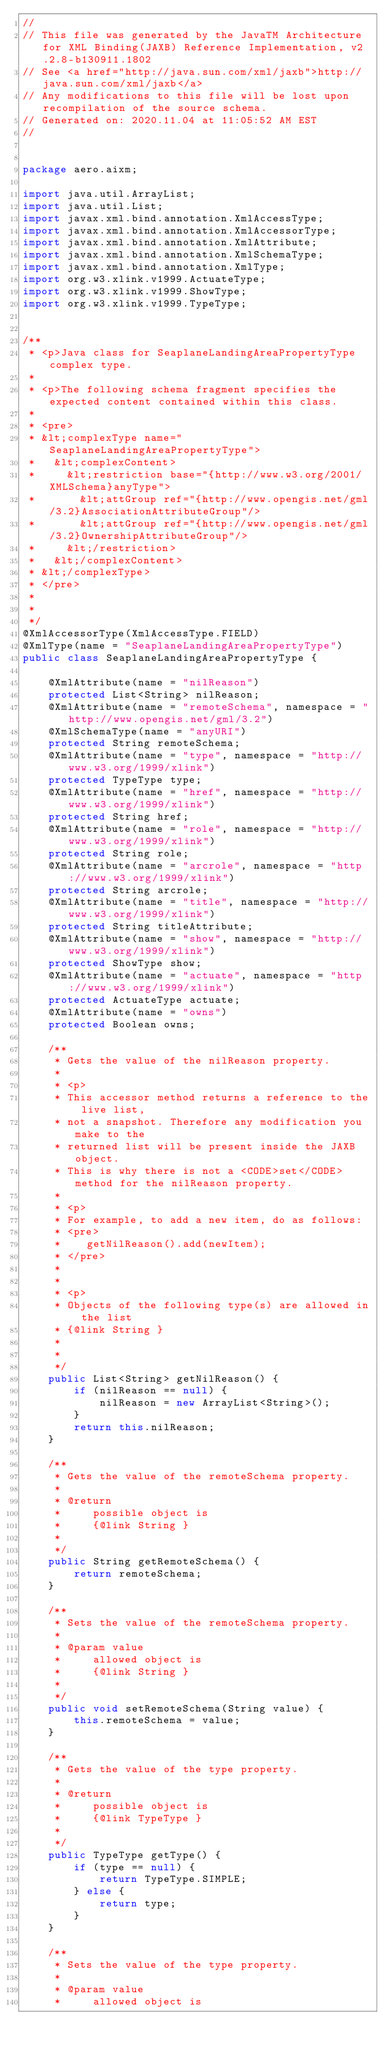<code> <loc_0><loc_0><loc_500><loc_500><_Java_>//
// This file was generated by the JavaTM Architecture for XML Binding(JAXB) Reference Implementation, v2.2.8-b130911.1802 
// See <a href="http://java.sun.com/xml/jaxb">http://java.sun.com/xml/jaxb</a> 
// Any modifications to this file will be lost upon recompilation of the source schema. 
// Generated on: 2020.11.04 at 11:05:52 AM EST 
//


package aero.aixm;

import java.util.ArrayList;
import java.util.List;
import javax.xml.bind.annotation.XmlAccessType;
import javax.xml.bind.annotation.XmlAccessorType;
import javax.xml.bind.annotation.XmlAttribute;
import javax.xml.bind.annotation.XmlSchemaType;
import javax.xml.bind.annotation.XmlType;
import org.w3.xlink.v1999.ActuateType;
import org.w3.xlink.v1999.ShowType;
import org.w3.xlink.v1999.TypeType;


/**
 * <p>Java class for SeaplaneLandingAreaPropertyType complex type.
 * 
 * <p>The following schema fragment specifies the expected content contained within this class.
 * 
 * <pre>
 * &lt;complexType name="SeaplaneLandingAreaPropertyType">
 *   &lt;complexContent>
 *     &lt;restriction base="{http://www.w3.org/2001/XMLSchema}anyType">
 *       &lt;attGroup ref="{http://www.opengis.net/gml/3.2}AssociationAttributeGroup"/>
 *       &lt;attGroup ref="{http://www.opengis.net/gml/3.2}OwnershipAttributeGroup"/>
 *     &lt;/restriction>
 *   &lt;/complexContent>
 * &lt;/complexType>
 * </pre>
 * 
 * 
 */
@XmlAccessorType(XmlAccessType.FIELD)
@XmlType(name = "SeaplaneLandingAreaPropertyType")
public class SeaplaneLandingAreaPropertyType {

    @XmlAttribute(name = "nilReason")
    protected List<String> nilReason;
    @XmlAttribute(name = "remoteSchema", namespace = "http://www.opengis.net/gml/3.2")
    @XmlSchemaType(name = "anyURI")
    protected String remoteSchema;
    @XmlAttribute(name = "type", namespace = "http://www.w3.org/1999/xlink")
    protected TypeType type;
    @XmlAttribute(name = "href", namespace = "http://www.w3.org/1999/xlink")
    protected String href;
    @XmlAttribute(name = "role", namespace = "http://www.w3.org/1999/xlink")
    protected String role;
    @XmlAttribute(name = "arcrole", namespace = "http://www.w3.org/1999/xlink")
    protected String arcrole;
    @XmlAttribute(name = "title", namespace = "http://www.w3.org/1999/xlink")
    protected String titleAttribute;
    @XmlAttribute(name = "show", namespace = "http://www.w3.org/1999/xlink")
    protected ShowType show;
    @XmlAttribute(name = "actuate", namespace = "http://www.w3.org/1999/xlink")
    protected ActuateType actuate;
    @XmlAttribute(name = "owns")
    protected Boolean owns;

    /**
     * Gets the value of the nilReason property.
     * 
     * <p>
     * This accessor method returns a reference to the live list,
     * not a snapshot. Therefore any modification you make to the
     * returned list will be present inside the JAXB object.
     * This is why there is not a <CODE>set</CODE> method for the nilReason property.
     * 
     * <p>
     * For example, to add a new item, do as follows:
     * <pre>
     *    getNilReason().add(newItem);
     * </pre>
     * 
     * 
     * <p>
     * Objects of the following type(s) are allowed in the list
     * {@link String }
     * 
     * 
     */
    public List<String> getNilReason() {
        if (nilReason == null) {
            nilReason = new ArrayList<String>();
        }
        return this.nilReason;
    }

    /**
     * Gets the value of the remoteSchema property.
     * 
     * @return
     *     possible object is
     *     {@link String }
     *     
     */
    public String getRemoteSchema() {
        return remoteSchema;
    }

    /**
     * Sets the value of the remoteSchema property.
     * 
     * @param value
     *     allowed object is
     *     {@link String }
     *     
     */
    public void setRemoteSchema(String value) {
        this.remoteSchema = value;
    }

    /**
     * Gets the value of the type property.
     * 
     * @return
     *     possible object is
     *     {@link TypeType }
     *     
     */
    public TypeType getType() {
        if (type == null) {
            return TypeType.SIMPLE;
        } else {
            return type;
        }
    }

    /**
     * Sets the value of the type property.
     * 
     * @param value
     *     allowed object is</code> 